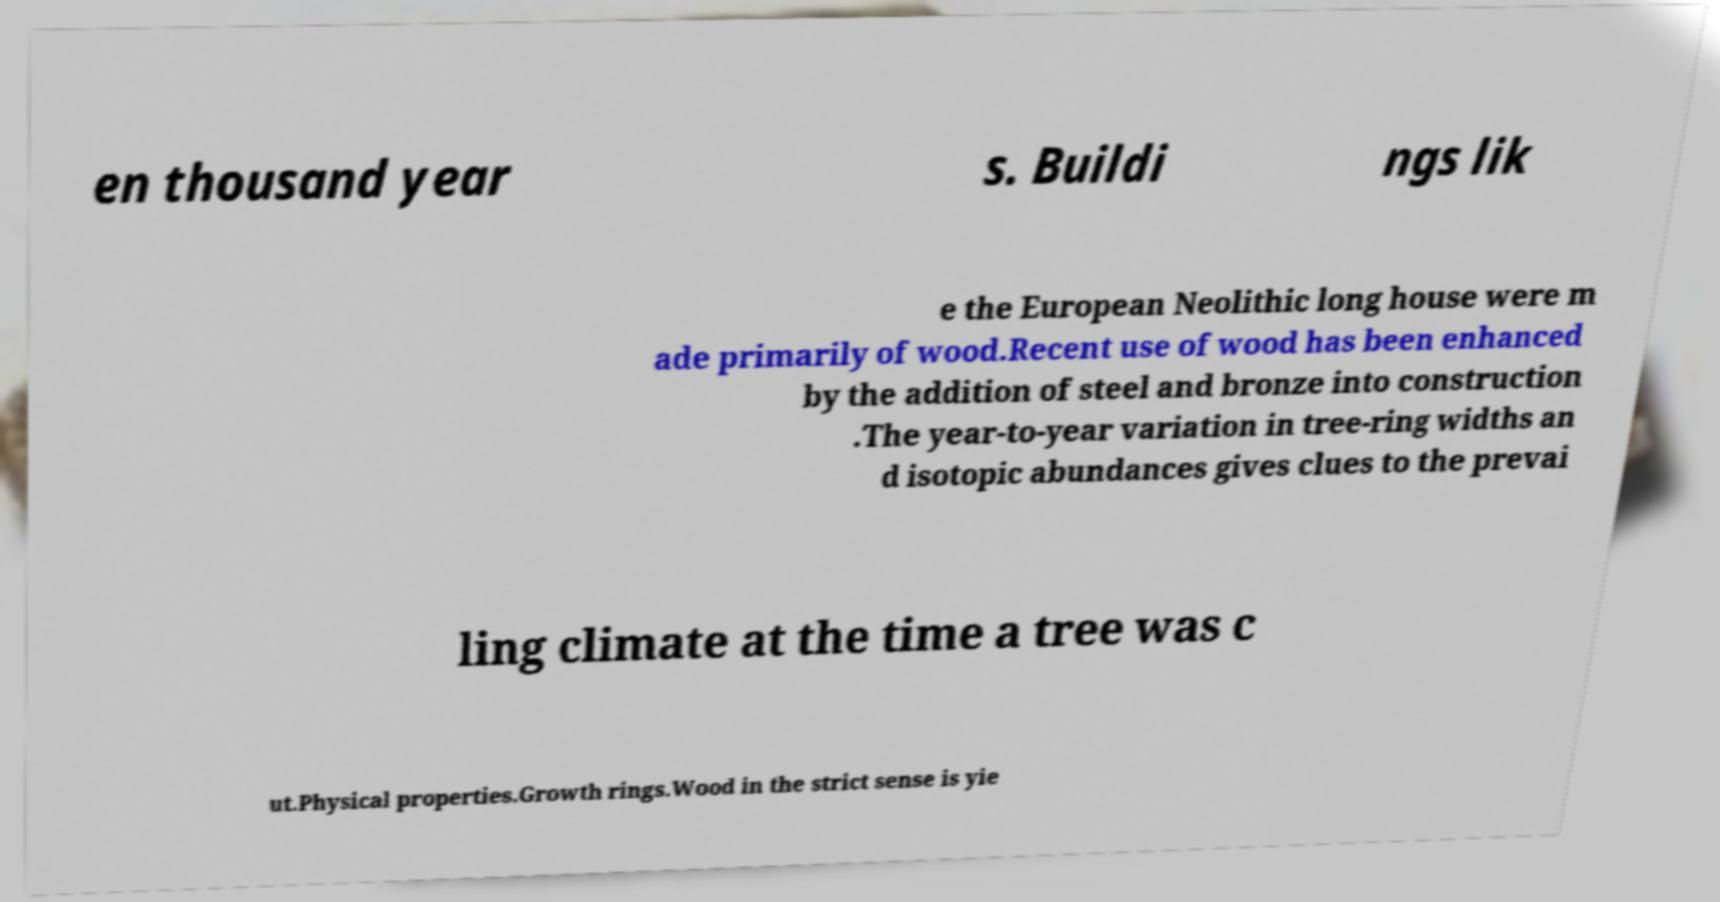What messages or text are displayed in this image? I need them in a readable, typed format. en thousand year s. Buildi ngs lik e the European Neolithic long house were m ade primarily of wood.Recent use of wood has been enhanced by the addition of steel and bronze into construction .The year-to-year variation in tree-ring widths an d isotopic abundances gives clues to the prevai ling climate at the time a tree was c ut.Physical properties.Growth rings.Wood in the strict sense is yie 